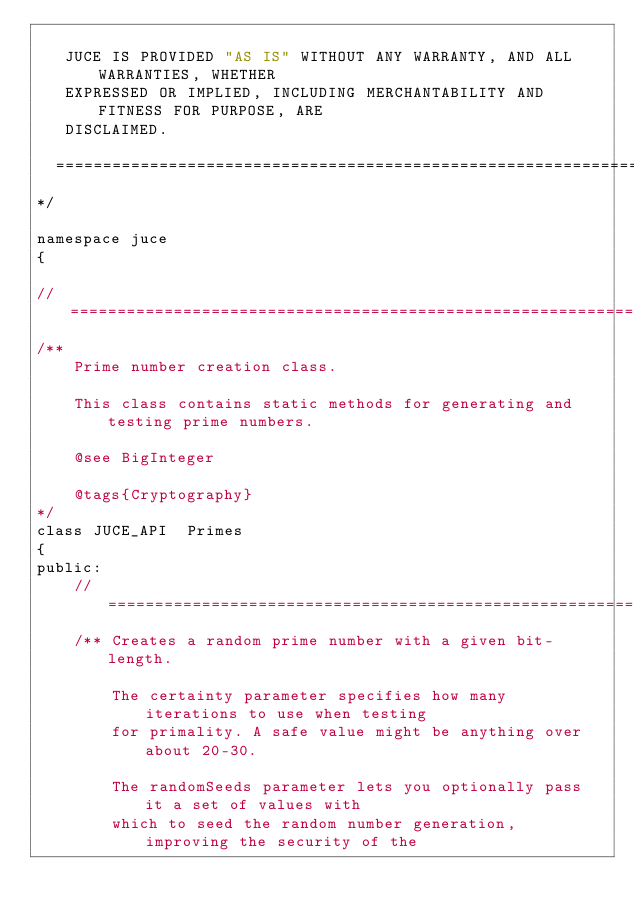Convert code to text. <code><loc_0><loc_0><loc_500><loc_500><_C_>
   JUCE IS PROVIDED "AS IS" WITHOUT ANY WARRANTY, AND ALL WARRANTIES, WHETHER
   EXPRESSED OR IMPLIED, INCLUDING MERCHANTABILITY AND FITNESS FOR PURPOSE, ARE
   DISCLAIMED.

  ==============================================================================
*/

namespace juce
{

//==============================================================================
/**
    Prime number creation class.

    This class contains static methods for generating and testing prime numbers.

    @see BigInteger

    @tags{Cryptography}
*/
class JUCE_API  Primes
{
public:
    //==============================================================================
    /** Creates a random prime number with a given bit-length.

        The certainty parameter specifies how many iterations to use when testing
        for primality. A safe value might be anything over about 20-30.

        The randomSeeds parameter lets you optionally pass it a set of values with
        which to seed the random number generation, improving the security of the</code> 